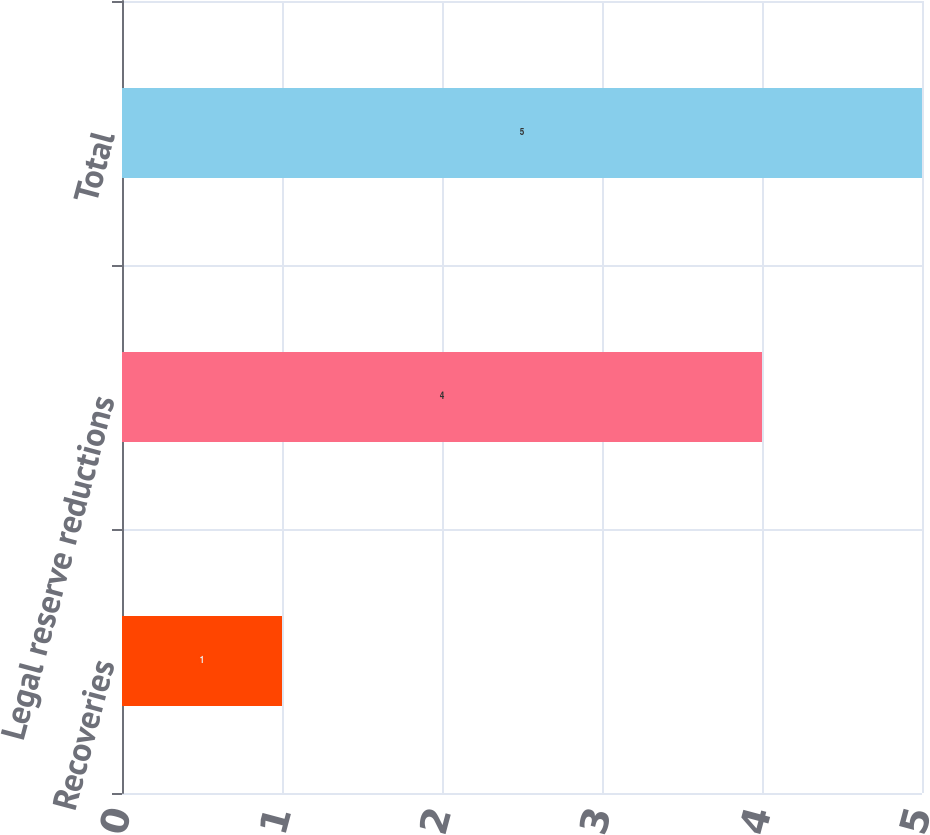Convert chart to OTSL. <chart><loc_0><loc_0><loc_500><loc_500><bar_chart><fcel>Recoveries<fcel>Legal reserve reductions<fcel>Total<nl><fcel>1<fcel>4<fcel>5<nl></chart> 